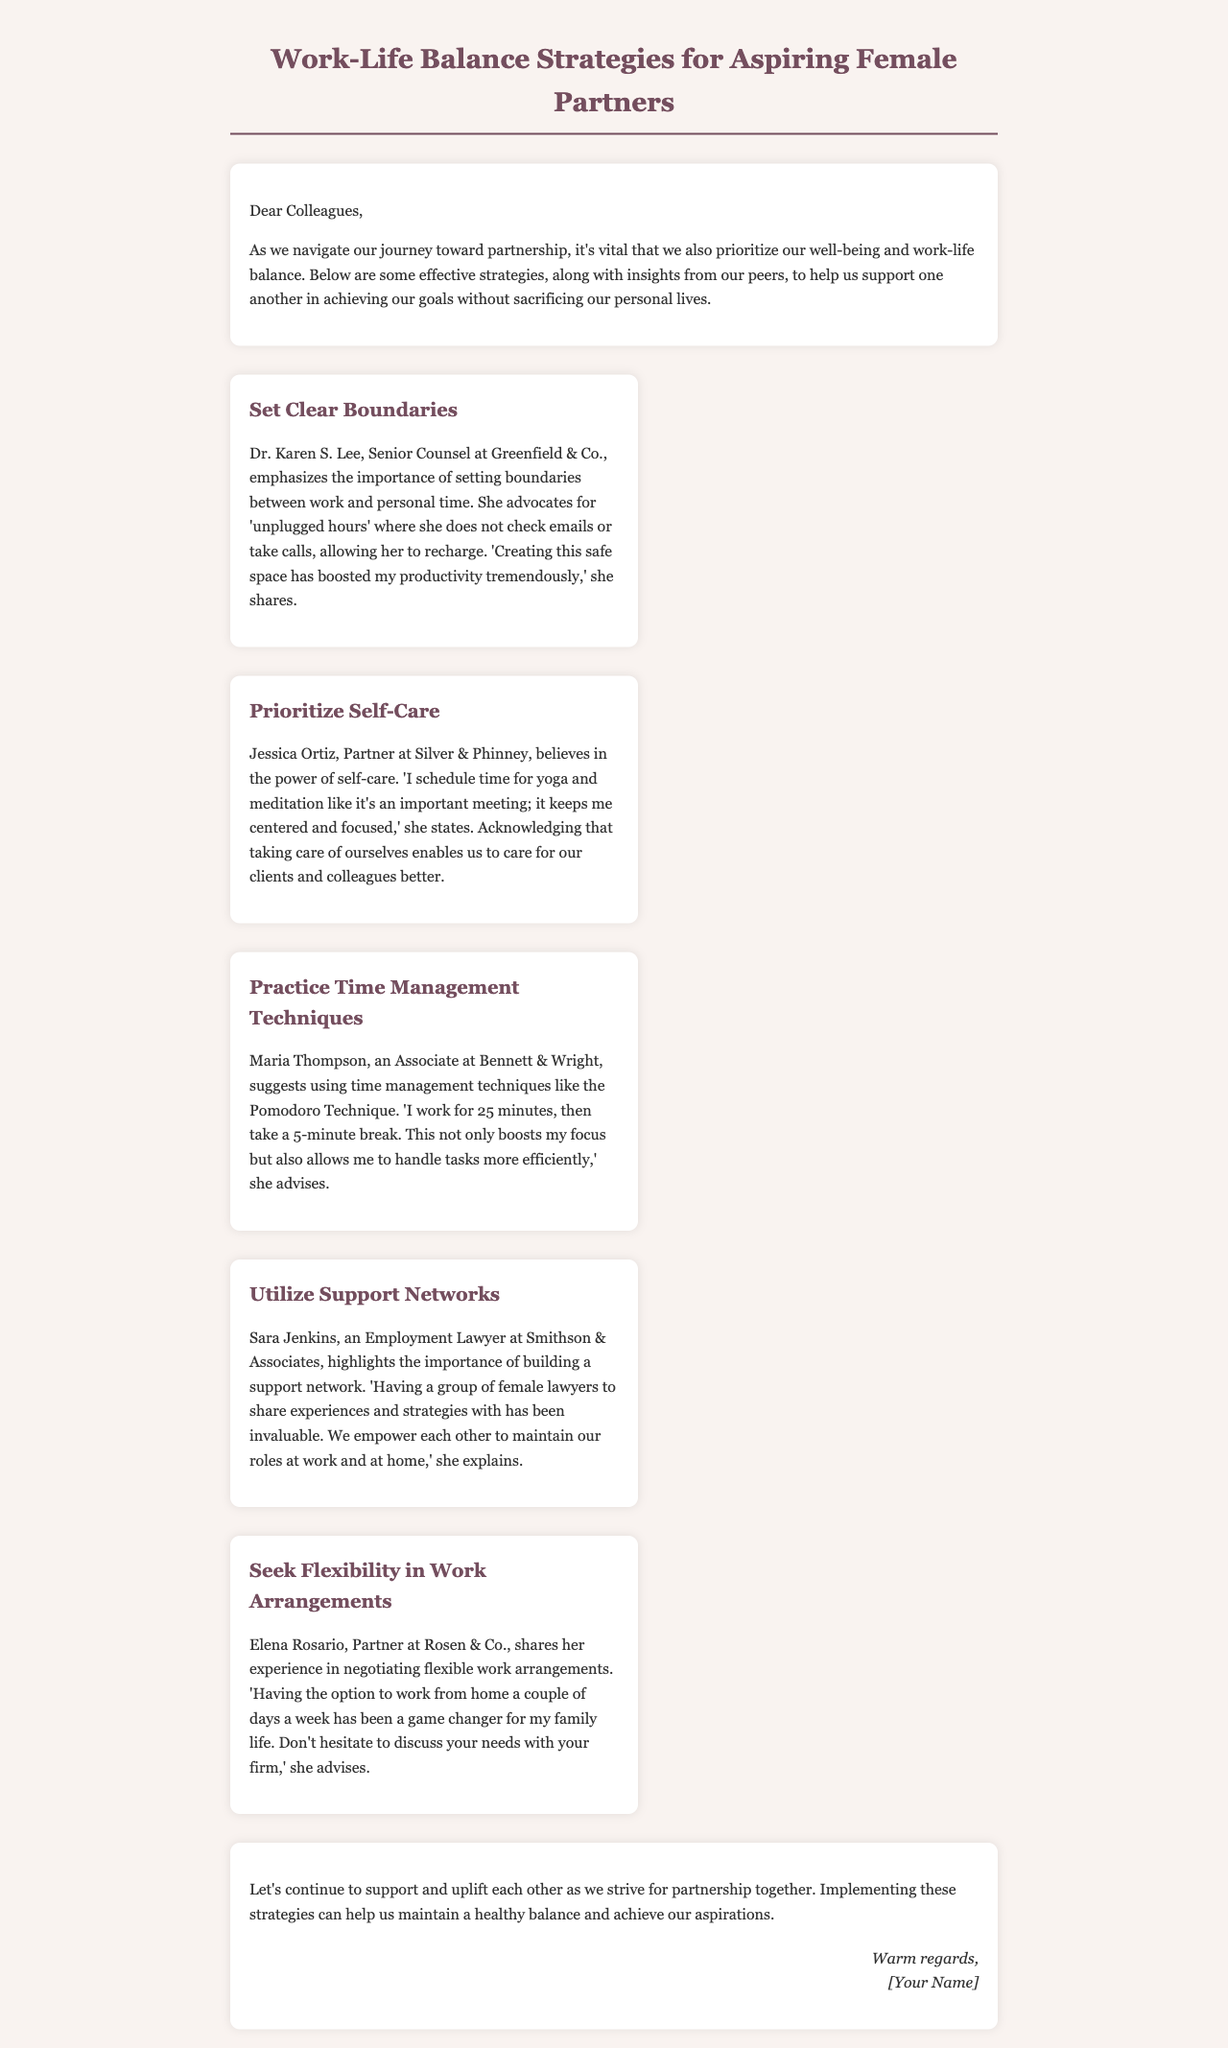What is the title of the document? The title of the document is specified in the <title> tag and covers the main topic discussed.
Answer: Work-Life Balance Strategies for Aspiring Female Partners Who is the Senior Counsel at Greenfield & Co.? This person's name and title are mentioned at the beginning of one strategy regarding setting boundaries.
Answer: Dr. Karen S. Lee What technique does Maria Thompson recommend? The technique is specifically identified in the section where Maria shares her time management strategy.
Answer: Pomodoro Technique Which partner shares her experience about negotiating flexibility? The individual who discusses this is highlighted in a specific strategy focused on work arrangements.
Answer: Elena Rosario What does Jessica Ortiz prioritize for self-care? This information is provided in the strategy discussing the importance of self-care.
Answer: Yoga and meditation How many strategies are provided in the document? The total number of strategies can be tallied based on the content structure featuring individual strategies.
Answer: Five 